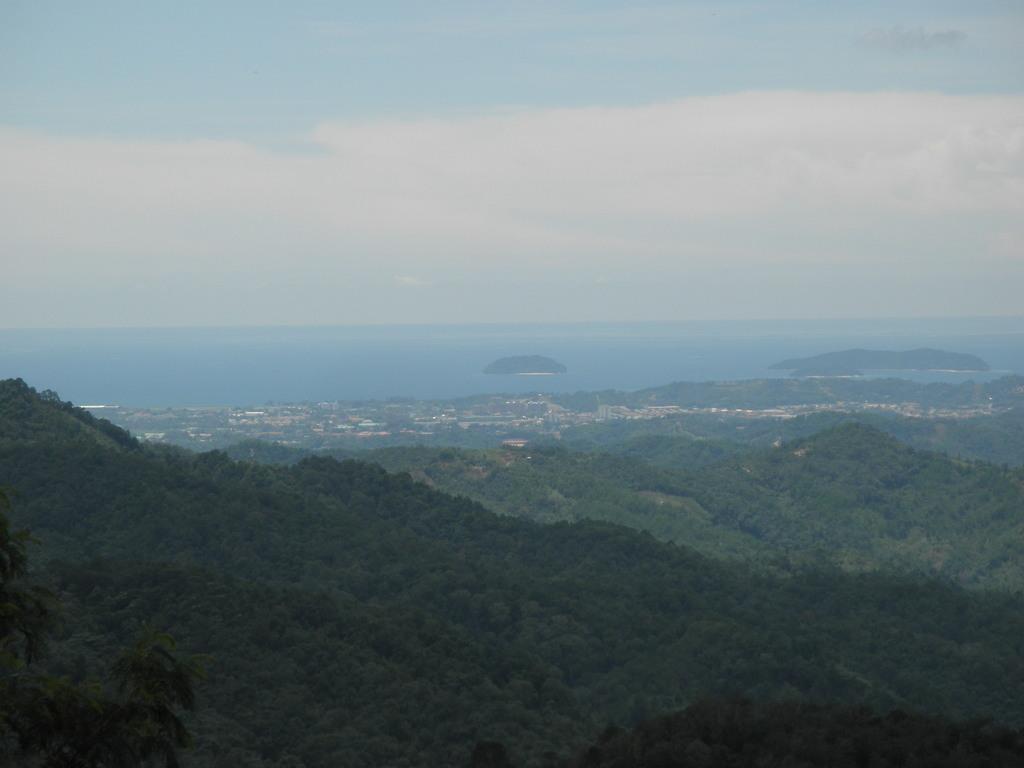Can you describe this image briefly? In this image we can see hills with trees. In the background there is water. Also there is sky with clouds. 